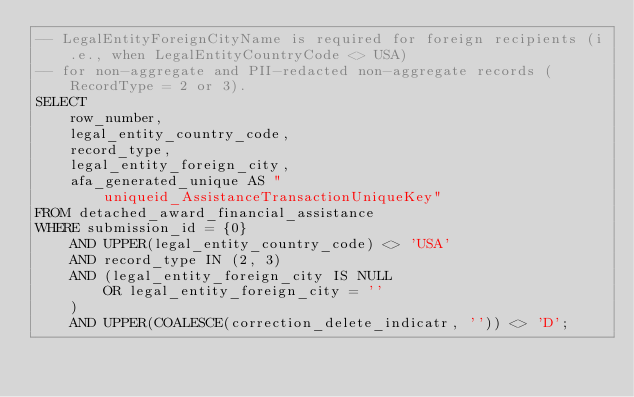<code> <loc_0><loc_0><loc_500><loc_500><_SQL_>-- LegalEntityForeignCityName is required for foreign recipients (i.e., when LegalEntityCountryCode <> USA)
-- for non-aggregate and PII-redacted non-aggregate records (RecordType = 2 or 3).
SELECT
    row_number,
    legal_entity_country_code,
    record_type,
    legal_entity_foreign_city,
    afa_generated_unique AS "uniqueid_AssistanceTransactionUniqueKey"
FROM detached_award_financial_assistance
WHERE submission_id = {0}
    AND UPPER(legal_entity_country_code) <> 'USA'
    AND record_type IN (2, 3)
    AND (legal_entity_foreign_city IS NULL
        OR legal_entity_foreign_city = ''
    )
    AND UPPER(COALESCE(correction_delete_indicatr, '')) <> 'D';
</code> 